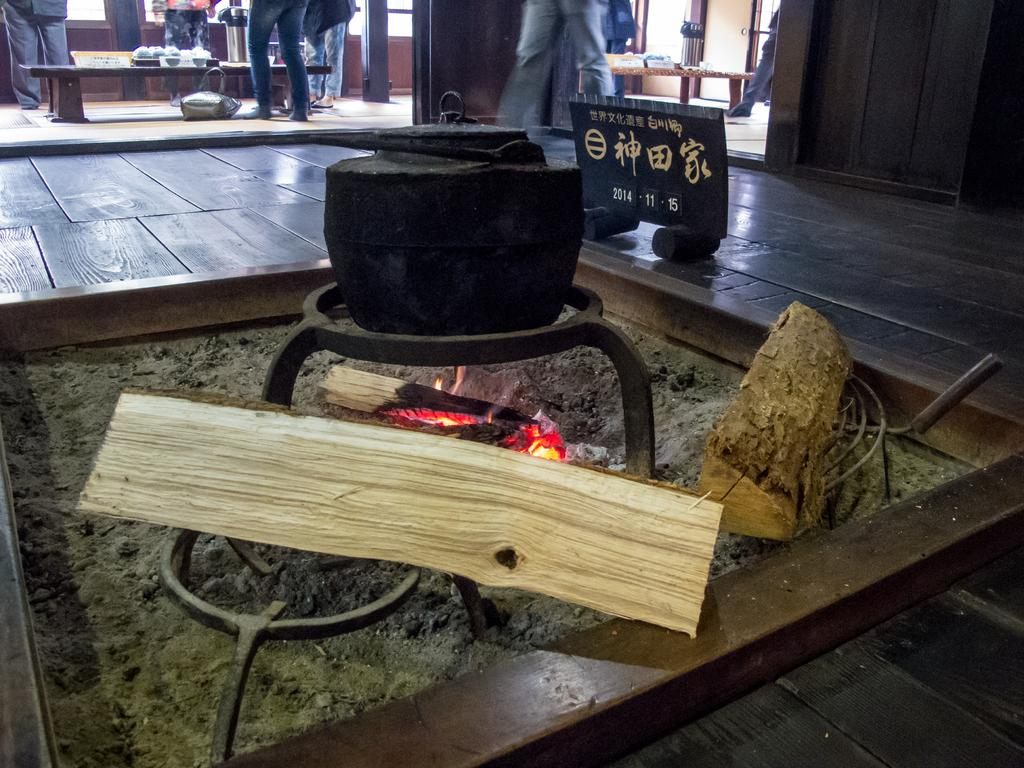What activity is taking place in the image? Cooking is happening on fire in the image. Can you describe the people in the image? There are persons standing on the floor in the image. What type of seating is available in the image? There are benches in the image. Is there any informational signage in the image? Yes, there is an information board in the image. How many tin mice are sitting on the wing in the image? There are no tin mice or wings present in the image. 